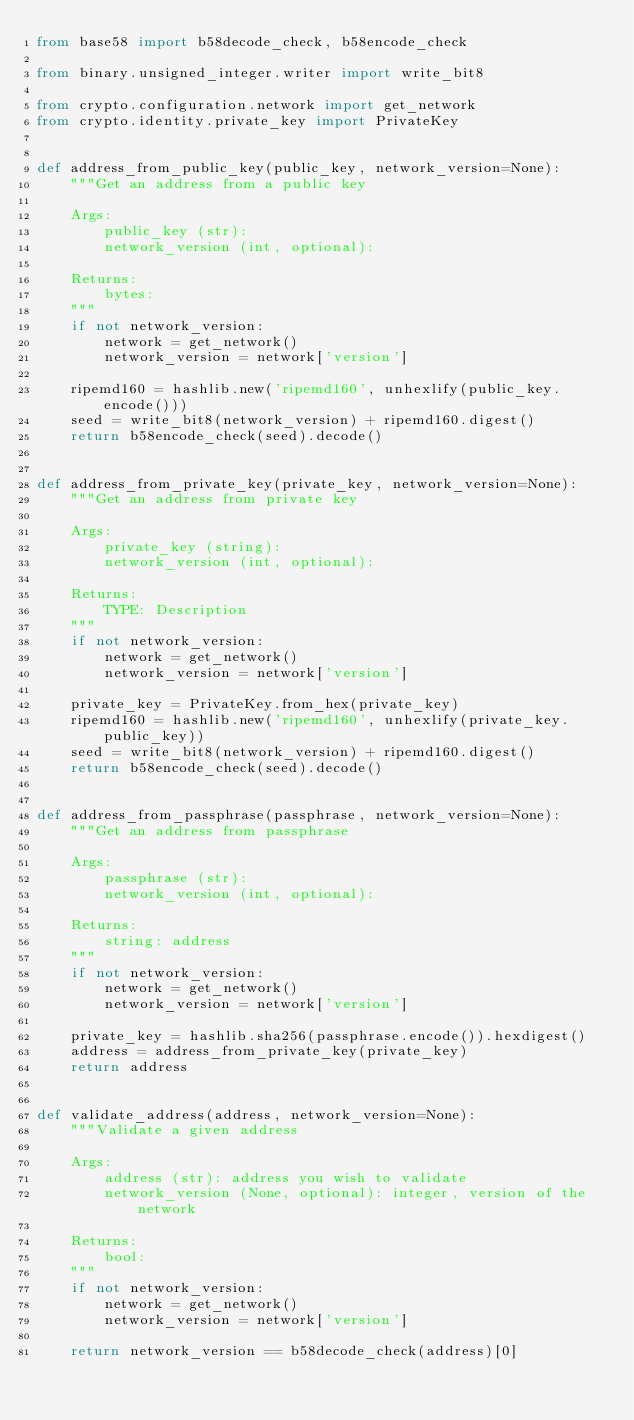<code> <loc_0><loc_0><loc_500><loc_500><_Python_>from base58 import b58decode_check, b58encode_check

from binary.unsigned_integer.writer import write_bit8

from crypto.configuration.network import get_network
from crypto.identity.private_key import PrivateKey


def address_from_public_key(public_key, network_version=None):
    """Get an address from a public key

    Args:
        public_key (str):
        network_version (int, optional):

    Returns:
        bytes:
    """
    if not network_version:
        network = get_network()
        network_version = network['version']

    ripemd160 = hashlib.new('ripemd160', unhexlify(public_key.encode()))
    seed = write_bit8(network_version) + ripemd160.digest()
    return b58encode_check(seed).decode()


def address_from_private_key(private_key, network_version=None):
    """Get an address from private key

    Args:
        private_key (string):
        network_version (int, optional):

    Returns:
        TYPE: Description
    """
    if not network_version:
        network = get_network()
        network_version = network['version']

    private_key = PrivateKey.from_hex(private_key)
    ripemd160 = hashlib.new('ripemd160', unhexlify(private_key.public_key))
    seed = write_bit8(network_version) + ripemd160.digest()
    return b58encode_check(seed).decode()


def address_from_passphrase(passphrase, network_version=None):
    """Get an address from passphrase

    Args:
        passphrase (str):
        network_version (int, optional):

    Returns:
        string: address
    """
    if not network_version:
        network = get_network()
        network_version = network['version']

    private_key = hashlib.sha256(passphrase.encode()).hexdigest()
    address = address_from_private_key(private_key)
    return address


def validate_address(address, network_version=None):
    """Validate a given address

    Args:
        address (str): address you wish to validate
        network_version (None, optional): integer, version of the network

    Returns:
        bool:
    """
    if not network_version:
        network = get_network()
        network_version = network['version']

    return network_version == b58decode_check(address)[0]
</code> 